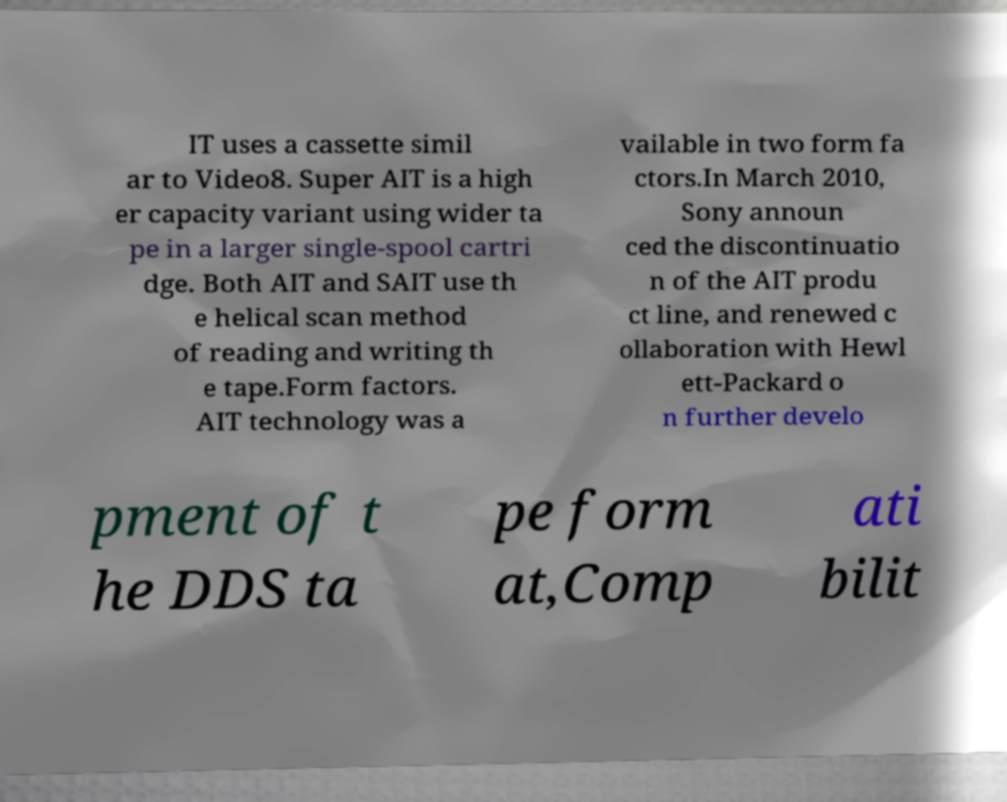Could you assist in decoding the text presented in this image and type it out clearly? IT uses a cassette simil ar to Video8. Super AIT is a high er capacity variant using wider ta pe in a larger single-spool cartri dge. Both AIT and SAIT use th e helical scan method of reading and writing th e tape.Form factors. AIT technology was a vailable in two form fa ctors.In March 2010, Sony announ ced the discontinuatio n of the AIT produ ct line, and renewed c ollaboration with Hewl ett-Packard o n further develo pment of t he DDS ta pe form at,Comp ati bilit 